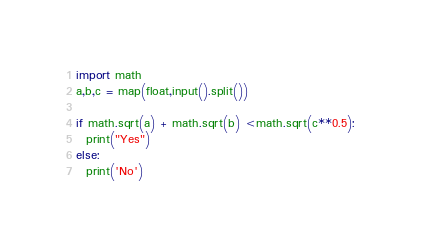<code> <loc_0><loc_0><loc_500><loc_500><_Python_>import math
a,b,c = map(float,input().split())

if math.sqrt(a) + math.sqrt(b) <math.sqrt(c**0.5):
  print("Yes")
else:
  print('No')
</code> 